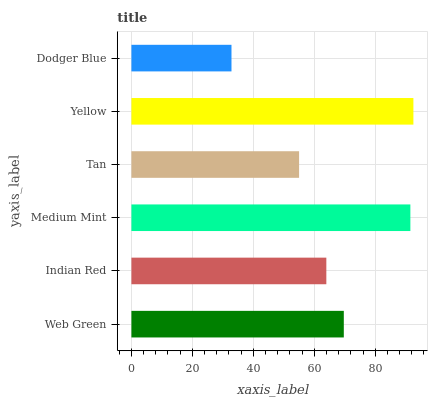Is Dodger Blue the minimum?
Answer yes or no. Yes. Is Yellow the maximum?
Answer yes or no. Yes. Is Indian Red the minimum?
Answer yes or no. No. Is Indian Red the maximum?
Answer yes or no. No. Is Web Green greater than Indian Red?
Answer yes or no. Yes. Is Indian Red less than Web Green?
Answer yes or no. Yes. Is Indian Red greater than Web Green?
Answer yes or no. No. Is Web Green less than Indian Red?
Answer yes or no. No. Is Web Green the high median?
Answer yes or no. Yes. Is Indian Red the low median?
Answer yes or no. Yes. Is Indian Red the high median?
Answer yes or no. No. Is Yellow the low median?
Answer yes or no. No. 